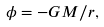<formula> <loc_0><loc_0><loc_500><loc_500>\phi = - G M / r ,</formula> 